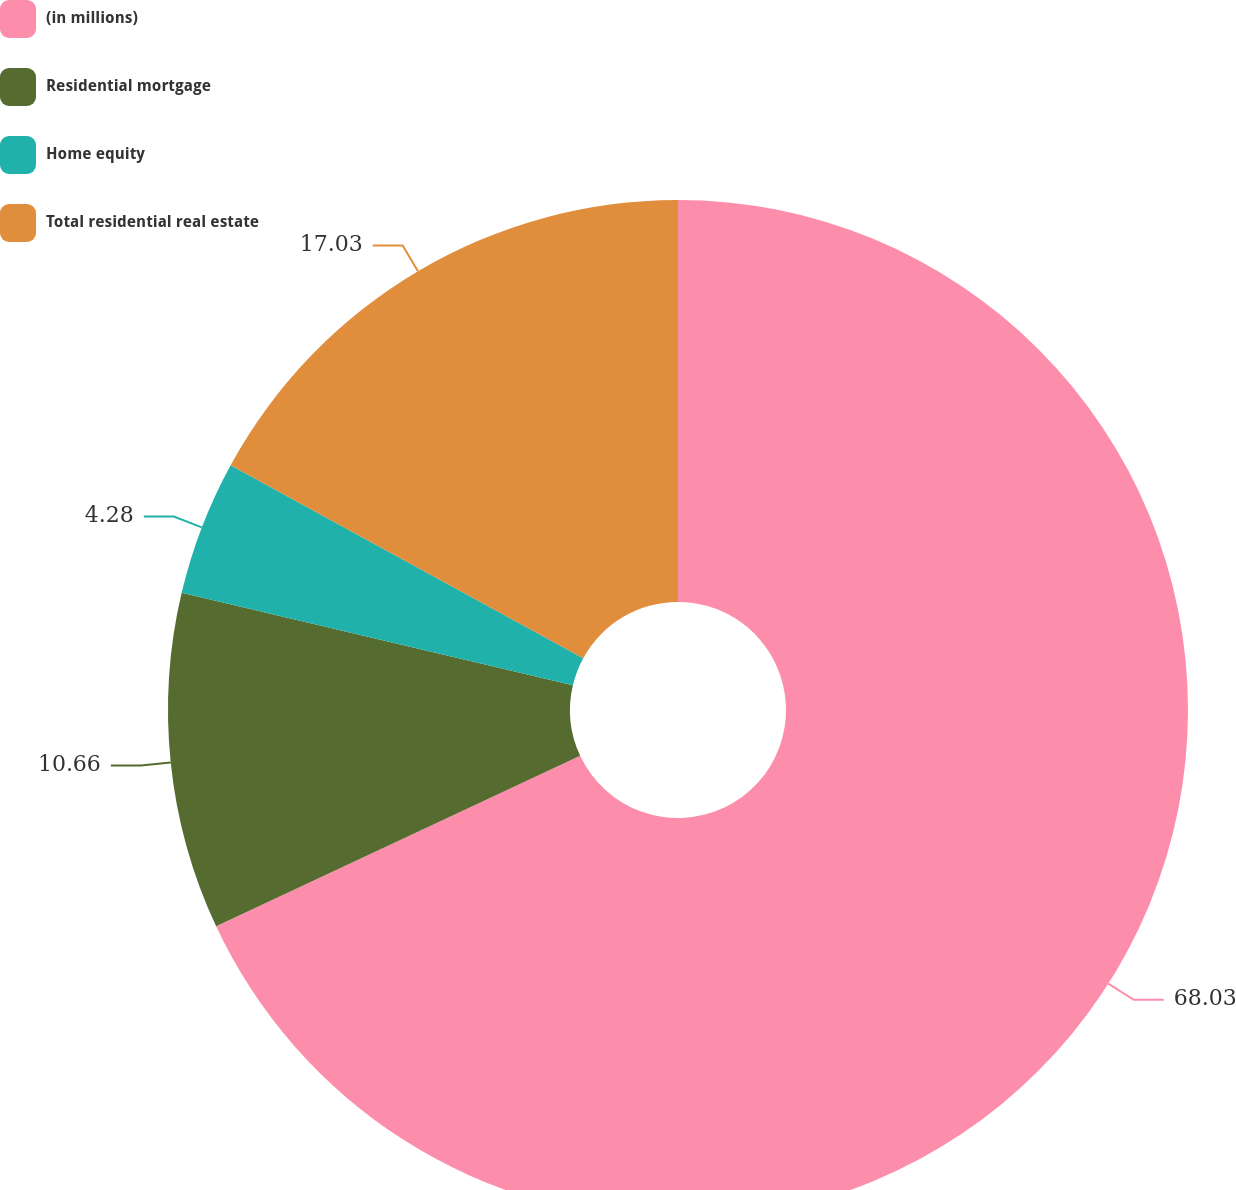Convert chart. <chart><loc_0><loc_0><loc_500><loc_500><pie_chart><fcel>(in millions)<fcel>Residential mortgage<fcel>Home equity<fcel>Total residential real estate<nl><fcel>68.03%<fcel>10.66%<fcel>4.28%<fcel>17.03%<nl></chart> 